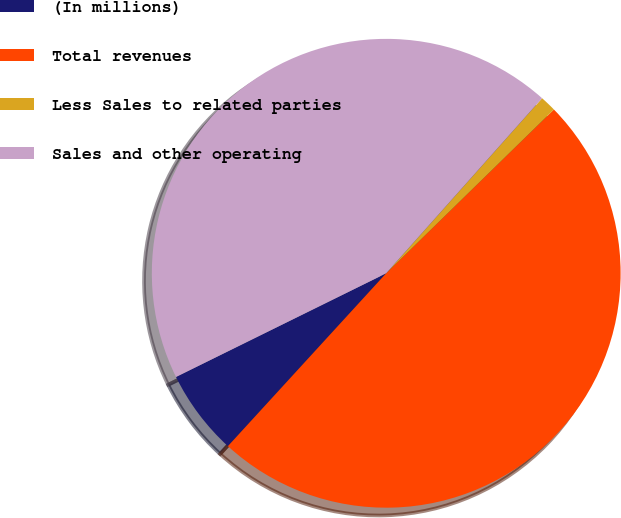Convert chart. <chart><loc_0><loc_0><loc_500><loc_500><pie_chart><fcel>(In millions)<fcel>Total revenues<fcel>Less Sales to related parties<fcel>Sales and other operating<nl><fcel>5.91%<fcel>49.11%<fcel>1.11%<fcel>43.87%<nl></chart> 